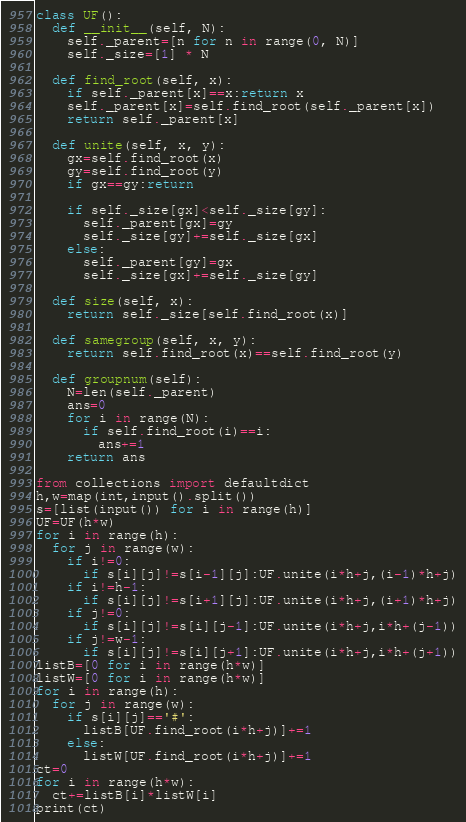<code> <loc_0><loc_0><loc_500><loc_500><_Python_>class UF():
  def __init__(self, N):
    self._parent=[n for n in range(0, N)]
    self._size=[1] * N

  def find_root(self, x):
    if self._parent[x]==x:return x
    self._parent[x]=self.find_root(self._parent[x])
    return self._parent[x]

  def unite(self, x, y):
    gx=self.find_root(x)
    gy=self.find_root(y)
    if gx==gy:return

    if self._size[gx]<self._size[gy]:
      self._parent[gx]=gy
      self._size[gy]+=self._size[gx]
    else:
      self._parent[gy]=gx
      self._size[gx]+=self._size[gy]

  def size(self, x):
    return self._size[self.find_root(x)]

  def samegroup(self, x, y):
    return self.find_root(x)==self.find_root(y)

  def groupnum(self):
    N=len(self._parent)
    ans=0
    for i in range(N):
      if self.find_root(i)==i:
        ans+=1
    return ans

from collections import defaultdict
h,w=map(int,input().split())
s=[list(input()) for i in range(h)]
UF=UF(h*w)
for i in range(h):
  for j in range(w):
    if i!=0:
      if s[i][j]!=s[i-1][j]:UF.unite(i*h+j,(i-1)*h+j)
    if i!=h-1:
      if s[i][j]!=s[i+1][j]:UF.unite(i*h+j,(i+1)*h+j)
    if j!=0:
      if s[i][j]!=s[i][j-1]:UF.unite(i*h+j,i*h+(j-1))
    if j!=w-1:
      if s[i][j]!=s[i][j+1]:UF.unite(i*h+j,i*h+(j+1))
listB=[0 for i in range(h*w)]
listW=[0 for i in range(h*w)]
for i in range(h):
  for j in range(w):
    if s[i][j]=='#':
      listB[UF.find_root(i*h+j)]+=1
    else:
      listW[UF.find_root(i*h+j)]+=1
ct=0
for i in range(h*w):
  ct+=listB[i]*listW[i]
print(ct)</code> 